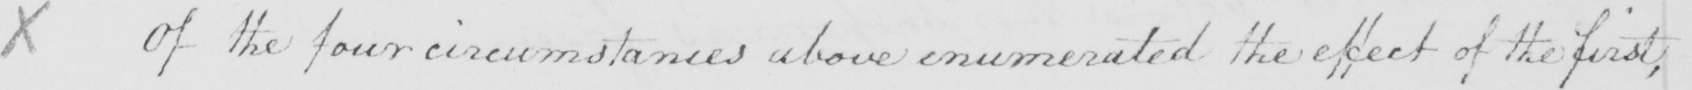Please transcribe the handwritten text in this image. X Of the four circumstances above enumerated the effect of the first , 